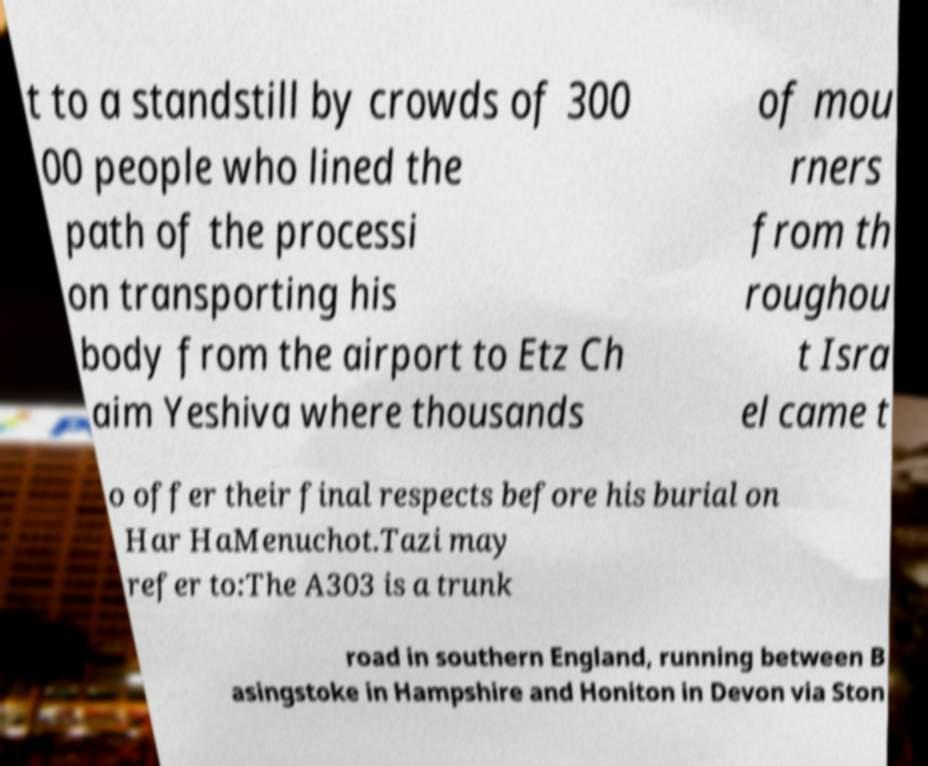Could you extract and type out the text from this image? t to a standstill by crowds of 300 00 people who lined the path of the processi on transporting his body from the airport to Etz Ch aim Yeshiva where thousands of mou rners from th roughou t Isra el came t o offer their final respects before his burial on Har HaMenuchot.Tazi may refer to:The A303 is a trunk road in southern England, running between B asingstoke in Hampshire and Honiton in Devon via Ston 